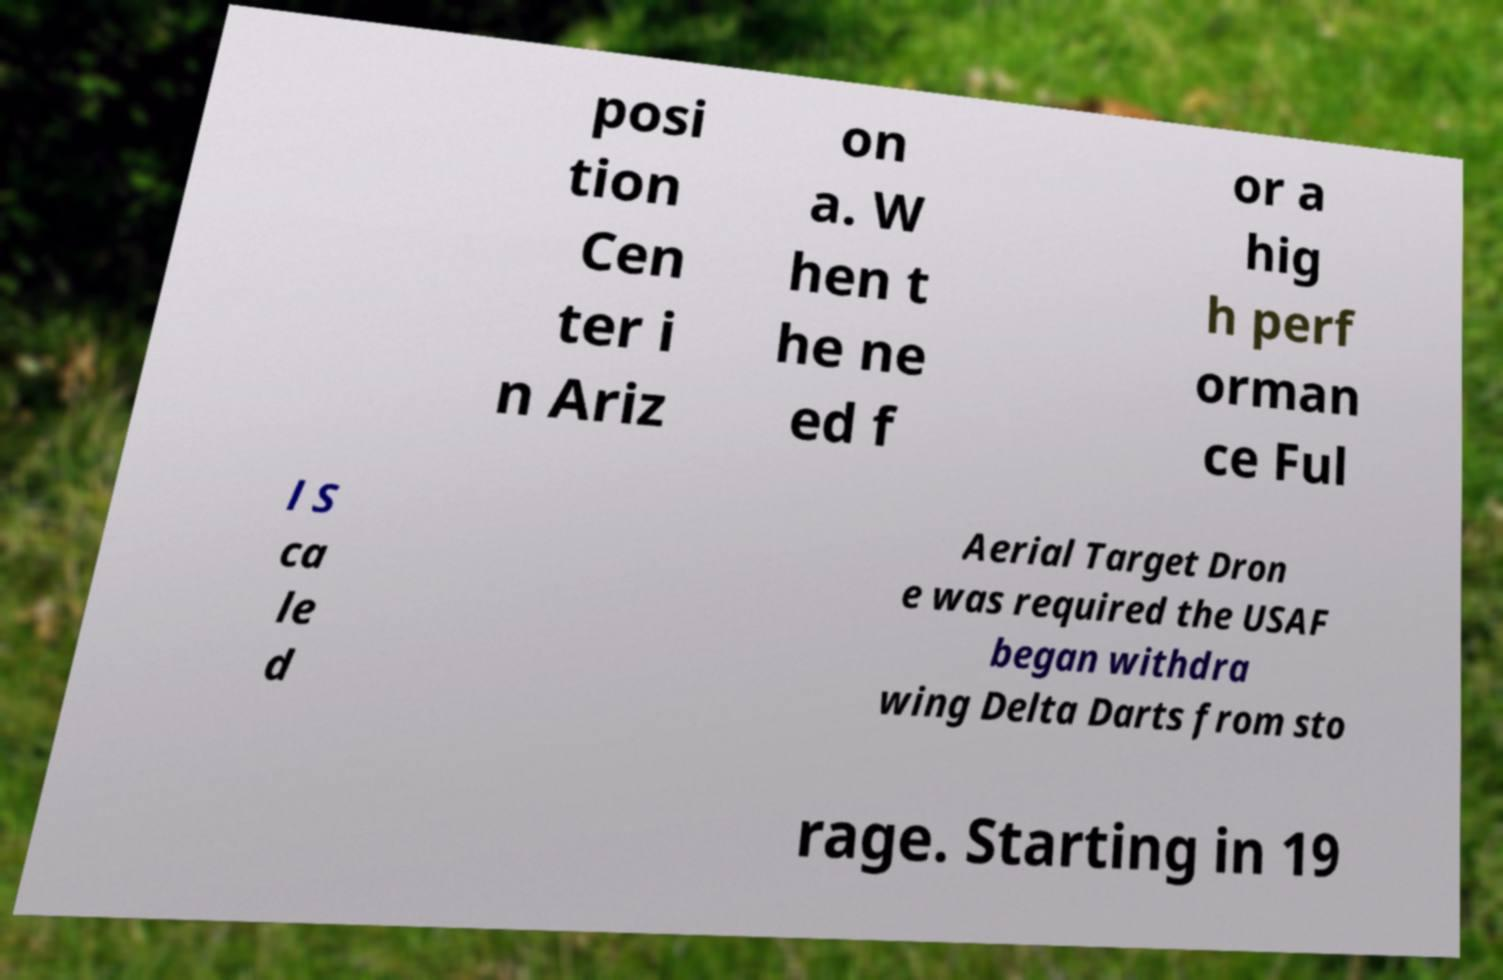Please read and relay the text visible in this image. What does it say? posi tion Cen ter i n Ariz on a. W hen t he ne ed f or a hig h perf orman ce Ful l S ca le d Aerial Target Dron e was required the USAF began withdra wing Delta Darts from sto rage. Starting in 19 